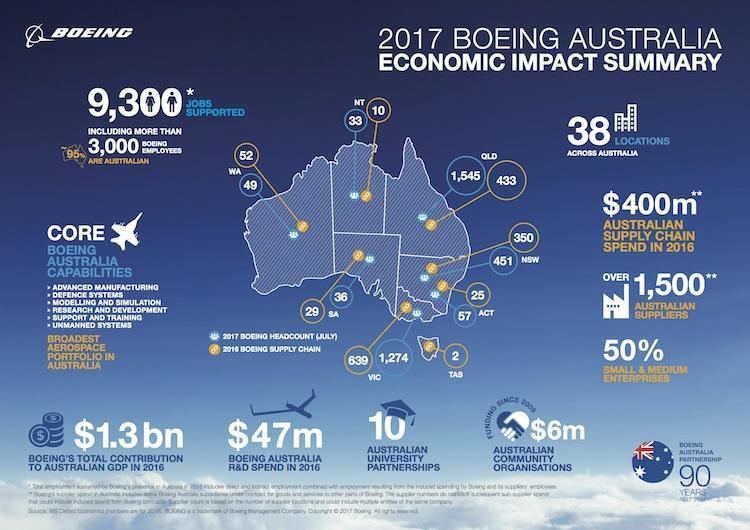What is difference in headcount is New South wales and Australian Capital Territory?
Answer the question with a short phrase. 394 